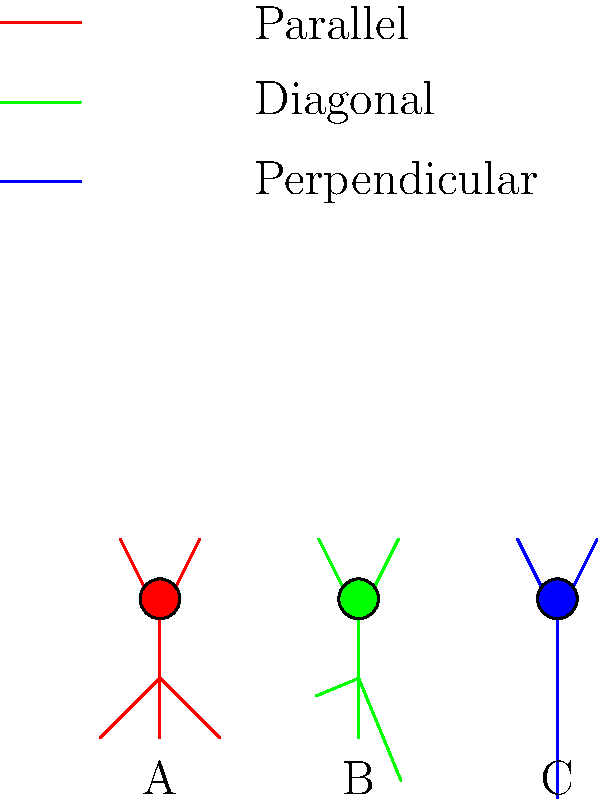Based on the biomechanical efficiency of arm swing techniques while running, as illustrated by the stick figure animations above, which technique (A, B, or C) is most likely to result in the highest energy expenditure and why? To determine which arm swing technique results in the highest energy expenditure, we need to consider the biomechanical principles of running efficiency:

1. Arm swing in running serves to counterbalance the rotation of the lower body and maintain stability.

2. The most efficient arm motion is one that minimizes unnecessary movement and energy expenditure while still providing balance.

3. Let's analyze each technique:

   A (Red): Arms swing parallel to the body's forward motion.
   - This technique minimizes lateral movement.
   - It keeps the arms close to the body's center of mass.
   - Energy is primarily directed in the running direction.

   B (Green): Arms swing diagonally across the body.
   - This technique introduces some lateral movement.
   - It may provide a slight counterbalance to lower body rotation.
   - Energy is partially directed sideways.

   C (Blue): Arms swing perpendicular to the running direction.
   - This technique maximizes lateral movement.
   - It creates significant resistance against the air.
   - Much energy is wasted on sideways motion.

4. Energy expenditure increases as more force is exerted against air resistance and in directions not contributing to forward motion.

5. The perpendicular arm swing (C) requires the most energy to overcome air resistance and does not contribute significantly to forward momentum.

6. The parallel arm swing (A) is generally considered the most efficient, as it minimizes unnecessary movement and focuses energy on forward motion.

7. The diagonal arm swing (B) falls between A and C in terms of efficiency.

Therefore, technique C (perpendicular arm swing) is most likely to result in the highest energy expenditure due to increased air resistance and wasted lateral motion.
Answer: C (perpendicular arm swing) 